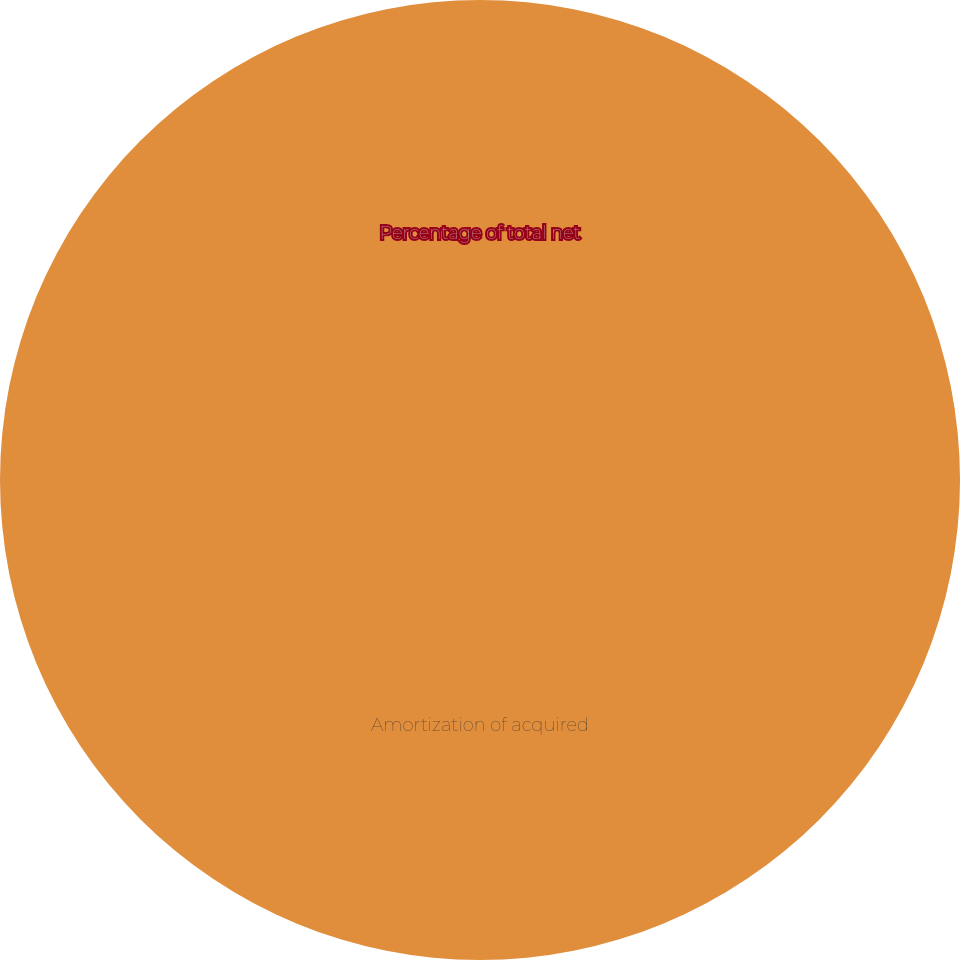<chart> <loc_0><loc_0><loc_500><loc_500><pie_chart><fcel>Amortization of acquired<fcel>Percentage of total net<nl><fcel>100.0%<fcel>0.0%<nl></chart> 